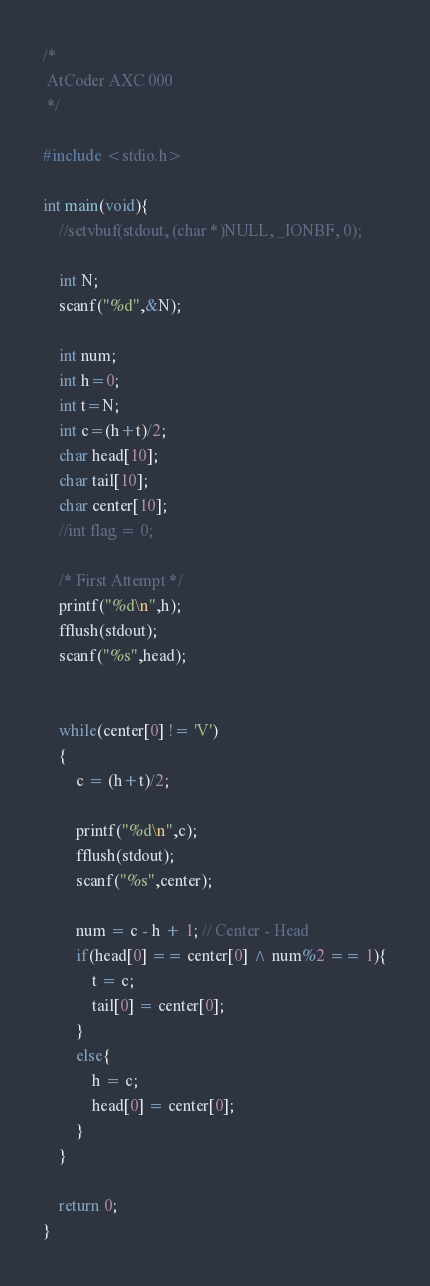<code> <loc_0><loc_0><loc_500><loc_500><_C_>/*
 AtCoder AXC 000
 */
 
#include <stdio.h>
 
int main(void){
	//setvbuf(stdout, (char *)NULL, _IONBF, 0);
	
	int N;
	scanf("%d",&N);
	
	int num;
	int h=0;
	int t=N;
	int c=(h+t)/2;
	char head[10];
	char tail[10];
	char center[10];
	//int flag = 0;
	
	/* First Attempt */
	printf("%d\n",h);
	fflush(stdout);
	scanf("%s",head);
	
	
	while(center[0] != 'V')
	{
		c = (h+t)/2;
		
		printf("%d\n",c);
		fflush(stdout);
		scanf("%s",center);
		
		num = c - h + 1; // Center - Head
		if(head[0] == center[0] ^ num%2 == 1){
			t = c;
			tail[0] = center[0];
		}
		else{
			h = c;
			head[0] = center[0];
		}
	}
	
	return 0;
}</code> 